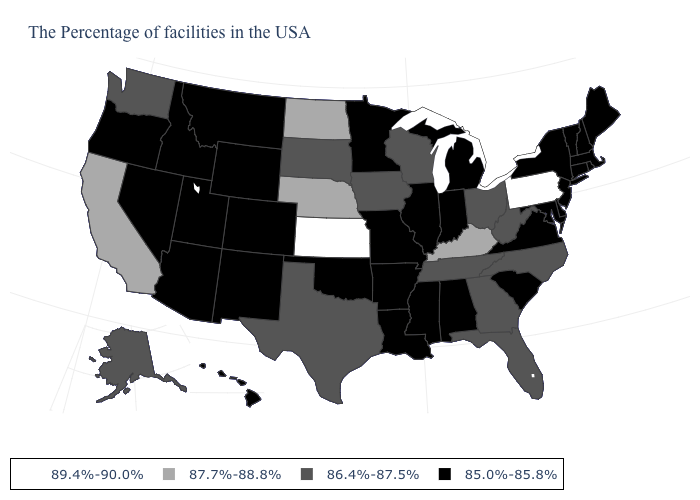What is the value of New York?
Be succinct. 85.0%-85.8%. Is the legend a continuous bar?
Write a very short answer. No. What is the value of Connecticut?
Answer briefly. 85.0%-85.8%. Does Pennsylvania have the highest value in the USA?
Quick response, please. Yes. What is the lowest value in the Northeast?
Keep it brief. 85.0%-85.8%. What is the value of West Virginia?
Keep it brief. 86.4%-87.5%. Name the states that have a value in the range 89.4%-90.0%?
Keep it brief. Pennsylvania, Kansas. Does the map have missing data?
Short answer required. No. Name the states that have a value in the range 87.7%-88.8%?
Short answer required. Kentucky, Nebraska, North Dakota, California. Among the states that border Wyoming , which have the highest value?
Give a very brief answer. Nebraska. What is the value of Wyoming?
Short answer required. 85.0%-85.8%. Name the states that have a value in the range 86.4%-87.5%?
Answer briefly. North Carolina, West Virginia, Ohio, Florida, Georgia, Tennessee, Wisconsin, Iowa, Texas, South Dakota, Washington, Alaska. What is the value of Texas?
Give a very brief answer. 86.4%-87.5%. Among the states that border New York , does Pennsylvania have the lowest value?
Give a very brief answer. No. Does Pennsylvania have the lowest value in the Northeast?
Quick response, please. No. 